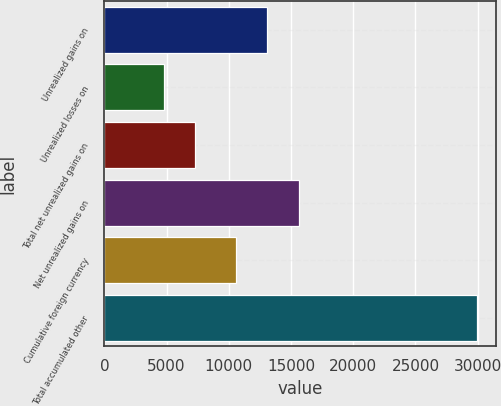Convert chart. <chart><loc_0><loc_0><loc_500><loc_500><bar_chart><fcel>Unrealized gains on<fcel>Unrealized losses on<fcel>Total net unrealized gains on<fcel>Net unrealized gains on<fcel>Cumulative foreign currency<fcel>Total accumulated other<nl><fcel>13095.6<fcel>4794<fcel>7309.6<fcel>15611.2<fcel>10580<fcel>29950<nl></chart> 